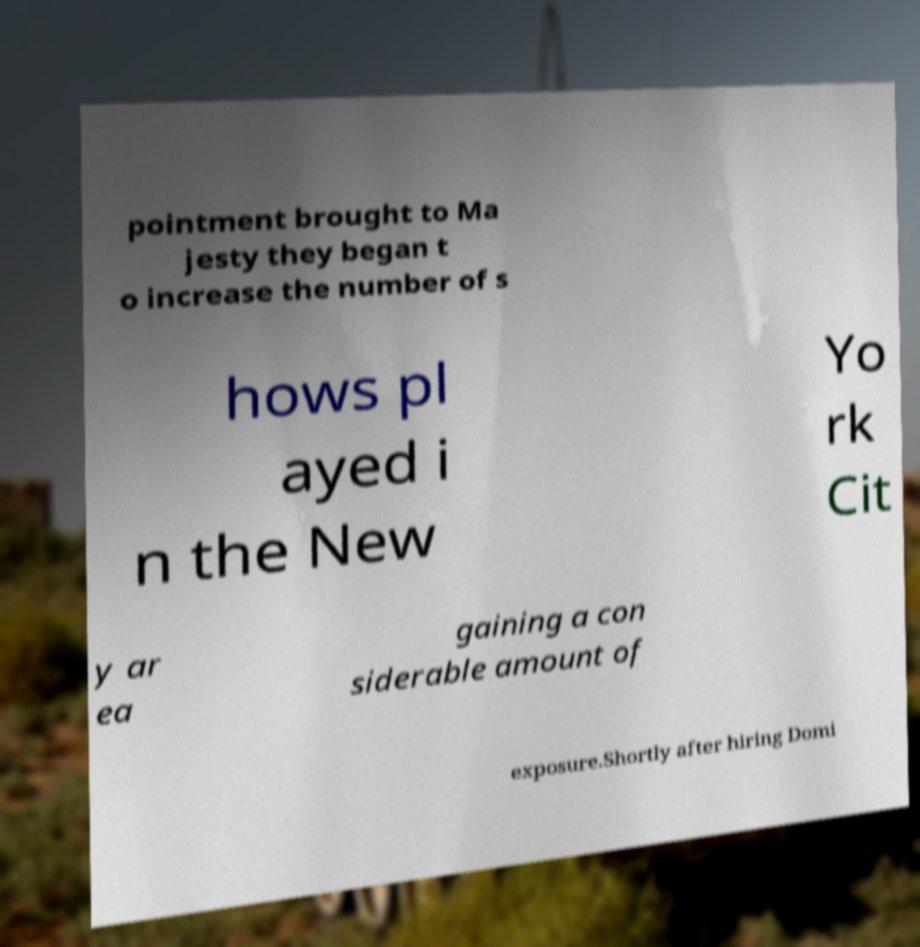Could you extract and type out the text from this image? pointment brought to Ma jesty they began t o increase the number of s hows pl ayed i n the New Yo rk Cit y ar ea gaining a con siderable amount of exposure.Shortly after hiring Domi 